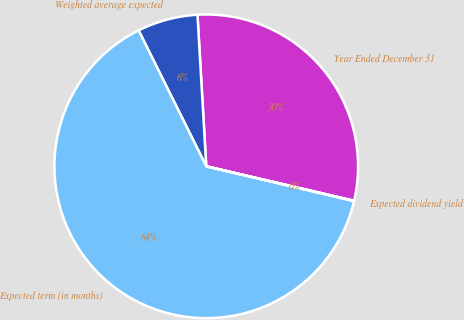Convert chart. <chart><loc_0><loc_0><loc_500><loc_500><pie_chart><fcel>Year Ended December 31<fcel>Weighted average expected<fcel>Expected term (in months)<fcel>Expected dividend yield<nl><fcel>29.56%<fcel>6.43%<fcel>63.96%<fcel>0.04%<nl></chart> 